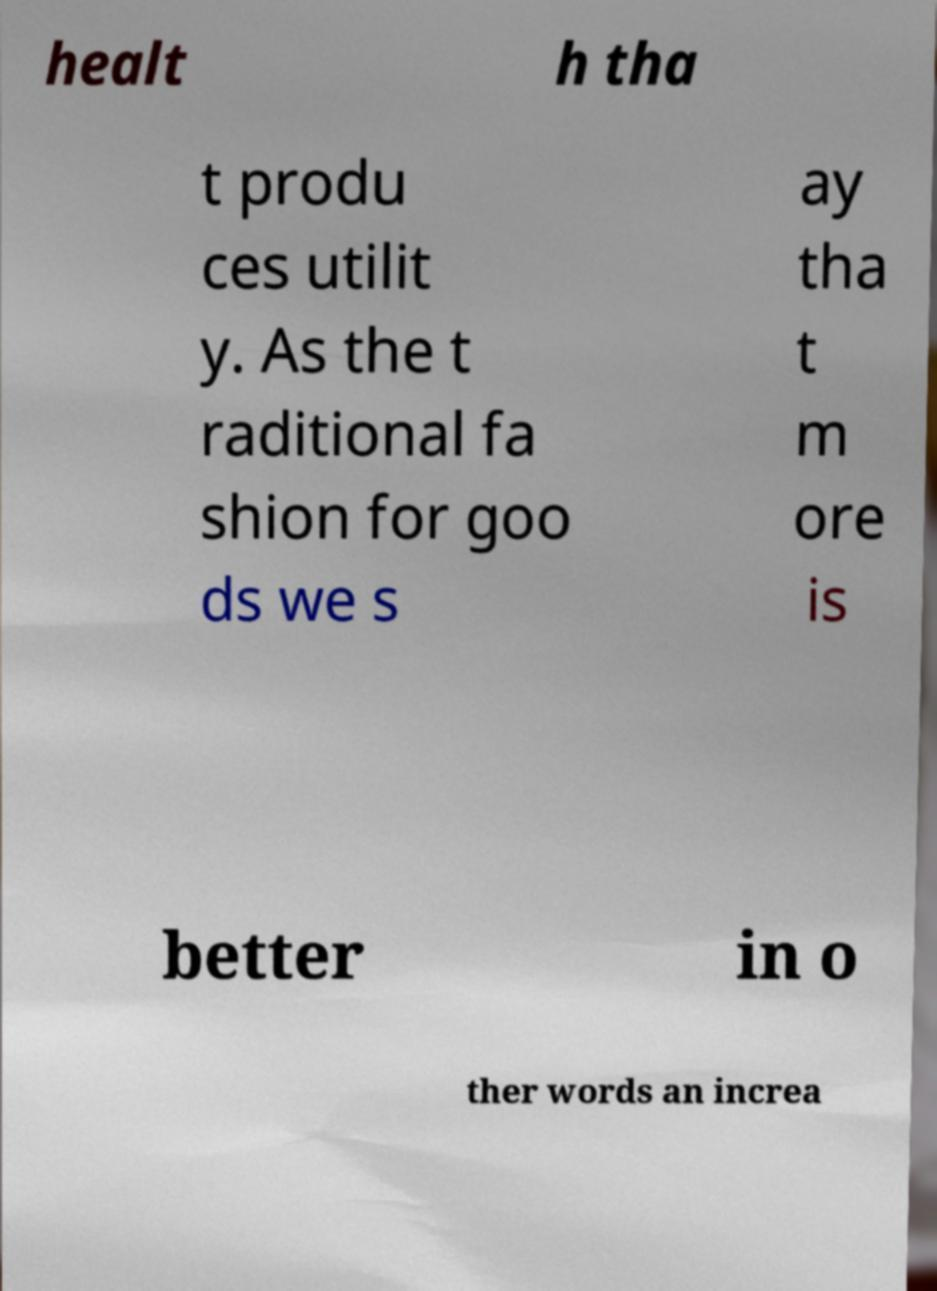Can you read and provide the text displayed in the image?This photo seems to have some interesting text. Can you extract and type it out for me? healt h tha t produ ces utilit y. As the t raditional fa shion for goo ds we s ay tha t m ore is better in o ther words an increa 